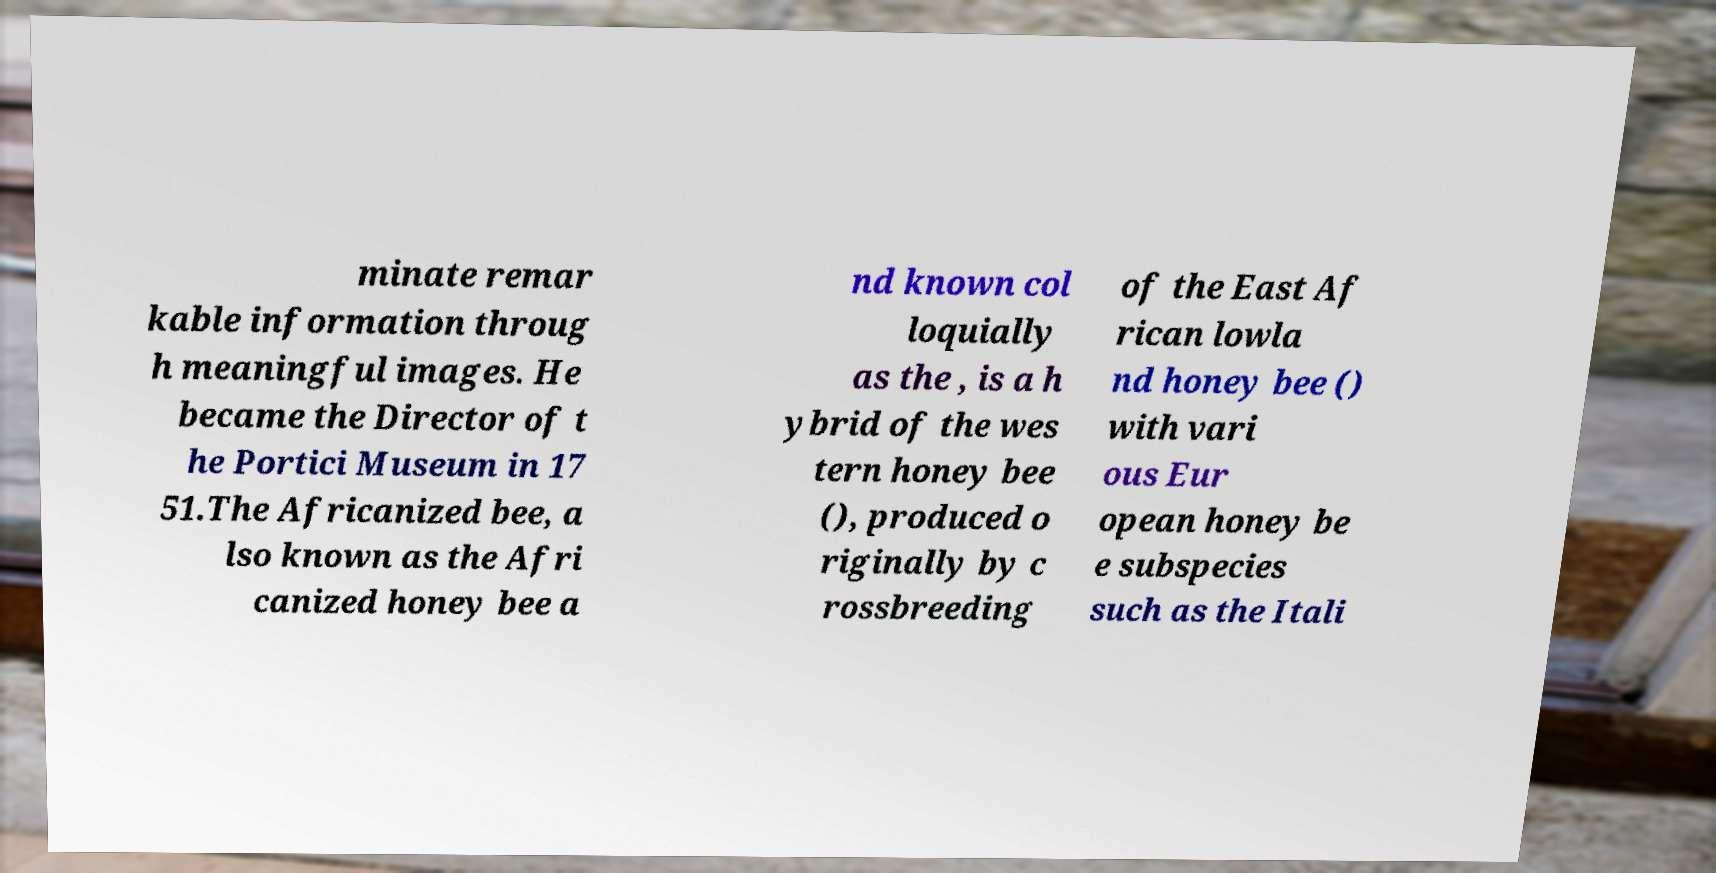What messages or text are displayed in this image? I need them in a readable, typed format. minate remar kable information throug h meaningful images. He became the Director of t he Portici Museum in 17 51.The Africanized bee, a lso known as the Afri canized honey bee a nd known col loquially as the , is a h ybrid of the wes tern honey bee (), produced o riginally by c rossbreeding of the East Af rican lowla nd honey bee () with vari ous Eur opean honey be e subspecies such as the Itali 